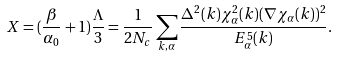Convert formula to latex. <formula><loc_0><loc_0><loc_500><loc_500>X = ( \frac { \beta } { \alpha _ { 0 } } + 1 ) \frac { \Lambda } { 3 } = \frac { 1 } { 2 N _ { c } } \sum _ { { k } , \alpha } \frac { \Delta ^ { 2 } ( { k } ) \chi ^ { 2 } _ { \alpha } ( { k } ) ( \nabla \chi _ { \alpha } ( { k } ) ) ^ { 2 } } { E _ { \alpha } ^ { 5 } ( { k } ) } .</formula> 